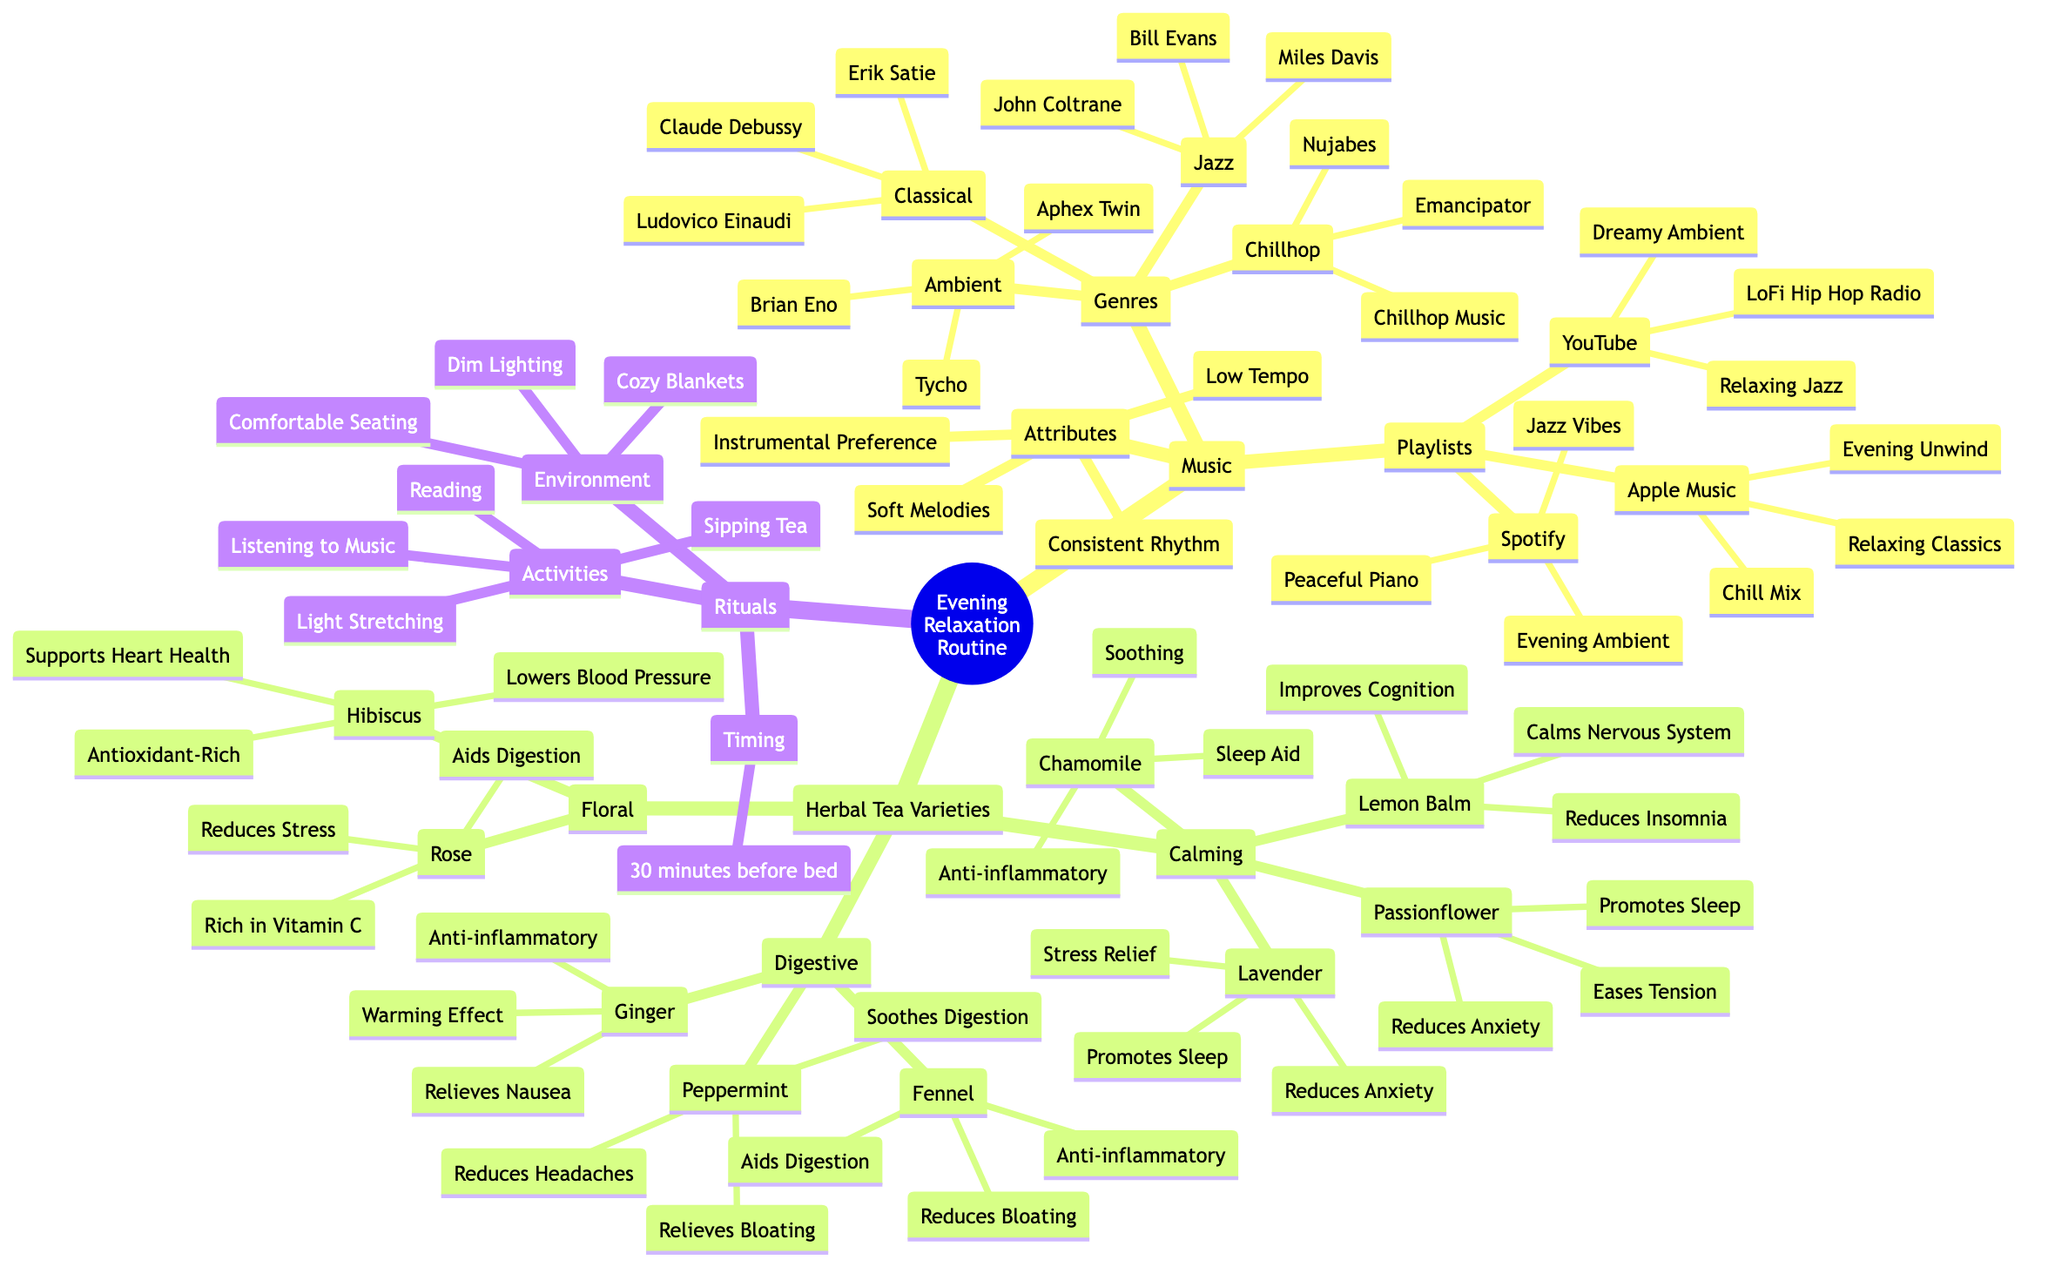What are the four main music genres in this relaxation routine? The diagram lists four main music genres under the Music category: Ambient, Classical, Jazz, and Chillhop.
Answer: Ambient, Classical, Jazz, Chillhop How many calming herbal tea varieties are listed? The diagram shows four varieties of calming herbal tea: Chamomile, Lavender, Lemon Balm, and Passionflower. Counting these gives a total of four varieties.
Answer: 4 What is the timing for the evening relaxation routine? The diagram specifies the timing for the evening relaxation routine as 30 minutes before bed. This detail is explicitly mentioned under the Rituals section.
Answer: 30 minutes before bed Which jazz artist is mentioned in the diagram? The diagram includes Bill Evans as one of the jazz artists listed under the Jazz genre in the Music section. Therefore, the answer is prominently found in that specific category.
Answer: Bill Evans What is the common benefit of Lavender tea? The diagram indicates that Lavender tea provides Stress Relief, Promotes Sleep, and Reduces Anxiety. Therefore, the common benefit can be identified as its calming effects on the mind and body.
Answer: Stress Relief How many playlists are suggested for Apple Music? In the Playlists section under Music, Apple Music lists three playlists: Relaxing Classics, Chill Mix, and Evening Unwind. Thus, counting these gives a total of three playlists specifically labeled for Apple Music.
Answer: 3 What type of environment is recommended for the routine? The diagram suggests an environment that includes Dim Lighting, Cozy Blankets, and Comfortable Seating, all contributing to a warm and inviting atmosphere for relaxation.
Answer: Dim Lighting, Cozy Blankets, Comfortable Seating Which tea is noted for aiding digestion? The diagram states that Rose tea is indicated for Aids Digestion, among other benefits, making it a key choice in the Digestive category of herbal teas.
Answer: Rose What are two activities mentioned in the rituals? The diagram lists several activities under Rituals, including Light Stretching and Reading, making these two activities a part of the relaxation routine.
Answer: Light Stretching, Reading 